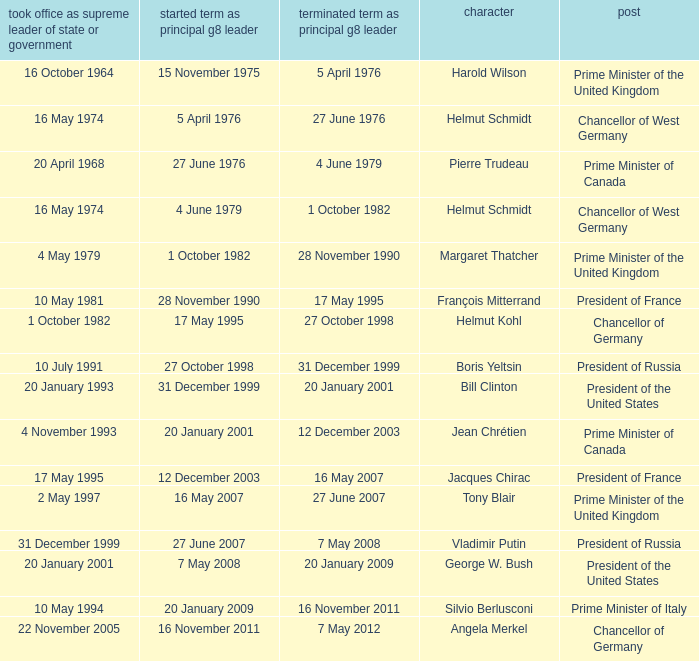When did Jacques Chirac stop being a G8 leader? 16 May 2007. Could you parse the entire table? {'header': ['took office as supreme leader of state or government', 'started term as principal g8 leader', 'terminated term as principal g8 leader', 'character', 'post'], 'rows': [['16 October 1964', '15 November 1975', '5 April 1976', 'Harold Wilson', 'Prime Minister of the United Kingdom'], ['16 May 1974', '5 April 1976', '27 June 1976', 'Helmut Schmidt', 'Chancellor of West Germany'], ['20 April 1968', '27 June 1976', '4 June 1979', 'Pierre Trudeau', 'Prime Minister of Canada'], ['16 May 1974', '4 June 1979', '1 October 1982', 'Helmut Schmidt', 'Chancellor of West Germany'], ['4 May 1979', '1 October 1982', '28 November 1990', 'Margaret Thatcher', 'Prime Minister of the United Kingdom'], ['10 May 1981', '28 November 1990', '17 May 1995', 'François Mitterrand', 'President of France'], ['1 October 1982', '17 May 1995', '27 October 1998', 'Helmut Kohl', 'Chancellor of Germany'], ['10 July 1991', '27 October 1998', '31 December 1999', 'Boris Yeltsin', 'President of Russia'], ['20 January 1993', '31 December 1999', '20 January 2001', 'Bill Clinton', 'President of the United States'], ['4 November 1993', '20 January 2001', '12 December 2003', 'Jean Chrétien', 'Prime Minister of Canada'], ['17 May 1995', '12 December 2003', '16 May 2007', 'Jacques Chirac', 'President of France'], ['2 May 1997', '16 May 2007', '27 June 2007', 'Tony Blair', 'Prime Minister of the United Kingdom'], ['31 December 1999', '27 June 2007', '7 May 2008', 'Vladimir Putin', 'President of Russia'], ['20 January 2001', '7 May 2008', '20 January 2009', 'George W. Bush', 'President of the United States'], ['10 May 1994', '20 January 2009', '16 November 2011', 'Silvio Berlusconi', 'Prime Minister of Italy'], ['22 November 2005', '16 November 2011', '7 May 2012', 'Angela Merkel', 'Chancellor of Germany']]} 